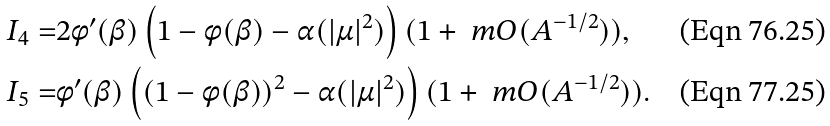<formula> <loc_0><loc_0><loc_500><loc_500>I _ { 4 } = & 2 \phi ^ { \prime } ( \beta ) \left ( 1 - \phi ( \beta ) - \alpha ( | \mu | ^ { 2 } ) \right ) ( 1 + \ m O ( A ^ { - 1 / 2 } ) ) , \\ I _ { 5 } = & \phi ^ { \prime } ( \beta ) \left ( ( 1 - \phi ( \beta ) ) ^ { 2 } - \alpha ( | \mu | ^ { 2 } ) \right ) ( 1 + \ m O ( A ^ { - 1 / 2 } ) ) .</formula> 